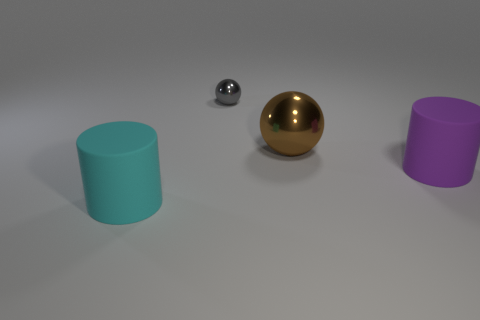How many objects are red balls or gray metallic things?
Offer a terse response. 1. What size is the rubber thing behind the rubber cylinder in front of the purple cylinder that is behind the cyan cylinder?
Provide a short and direct response. Large. What number of other metallic balls are the same color as the small metal ball?
Give a very brief answer. 0. What number of tiny things have the same material as the purple cylinder?
Give a very brief answer. 0. How many objects are big brown rubber blocks or cylinders left of the small shiny sphere?
Ensure brevity in your answer.  1. There is a object that is behind the ball in front of the tiny gray object behind the brown shiny object; what color is it?
Keep it short and to the point. Gray. There is a metallic thing right of the small gray metal ball; how big is it?
Keep it short and to the point. Large. What number of small objects are rubber objects or purple rubber cubes?
Your answer should be compact. 0. The object that is both left of the purple cylinder and in front of the brown sphere is what color?
Give a very brief answer. Cyan. Are there any cyan objects of the same shape as the tiny gray metal thing?
Offer a terse response. No. 